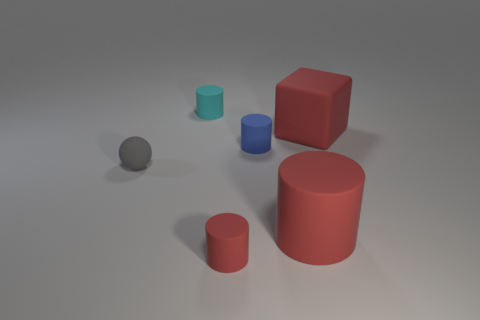What number of gray rubber things are the same size as the cyan thing?
Provide a succinct answer. 1. Is the number of red rubber cylinders behind the rubber sphere less than the number of tiny blue objects?
Give a very brief answer. Yes. What is the size of the thing that is left of the cylinder that is behind the blue rubber thing?
Make the answer very short. Small. How many objects are either tiny blue balls or tiny gray rubber objects?
Your answer should be compact. 1. Are there any rubber things that have the same color as the big block?
Your answer should be very brief. Yes. Is the number of purple objects less than the number of red matte cylinders?
Your answer should be compact. Yes. How many objects are either matte cylinders or matte cylinders that are left of the big cylinder?
Offer a very short reply. 4. Are there any tiny purple things made of the same material as the gray ball?
Offer a very short reply. No. What material is the sphere that is the same size as the blue matte cylinder?
Make the answer very short. Rubber. The red cylinder in front of the big matte thing in front of the small gray rubber thing is made of what material?
Keep it short and to the point. Rubber. 